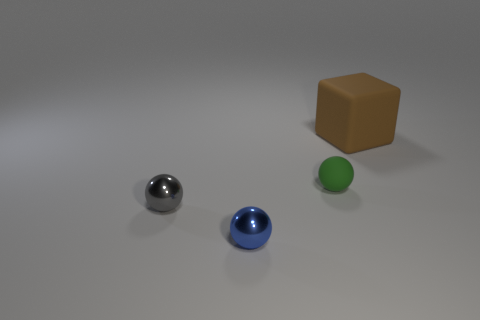Add 3 big blue rubber spheres. How many objects exist? 7 Subtract all spheres. How many objects are left? 1 Subtract all big blocks. Subtract all brown things. How many objects are left? 2 Add 2 green spheres. How many green spheres are left? 3 Add 1 gray things. How many gray things exist? 2 Subtract 0 yellow blocks. How many objects are left? 4 